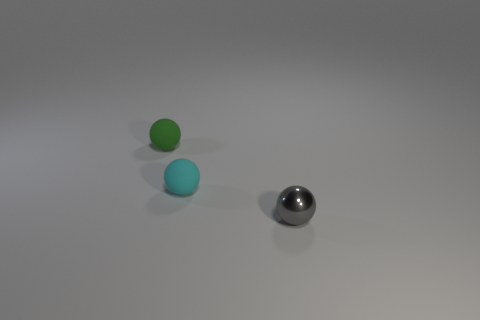How big is the thing that is in front of the tiny cyan matte object?
Make the answer very short. Small. What color is the tiny matte thing in front of the tiny object that is behind the matte ball on the right side of the small green rubber thing?
Offer a very short reply. Cyan. There is a small matte sphere that is in front of the tiny sphere that is to the left of the small cyan matte sphere; what is its color?
Keep it short and to the point. Cyan. Is the number of small gray metal objects behind the green ball greater than the number of metallic things behind the tiny gray sphere?
Provide a short and direct response. No. Is the material of the tiny object in front of the small cyan ball the same as the sphere behind the tiny cyan rubber object?
Your answer should be compact. No. Are there any small cyan spheres in front of the tiny metal thing?
Make the answer very short. No. How many cyan objects are balls or tiny shiny balls?
Ensure brevity in your answer.  1. Is the tiny green thing made of the same material as the small ball on the right side of the tiny cyan object?
Your answer should be very brief. No. There is a metal thing that is the same shape as the tiny cyan rubber thing; what is its size?
Offer a terse response. Small. What is the material of the small cyan object?
Make the answer very short. Rubber. 